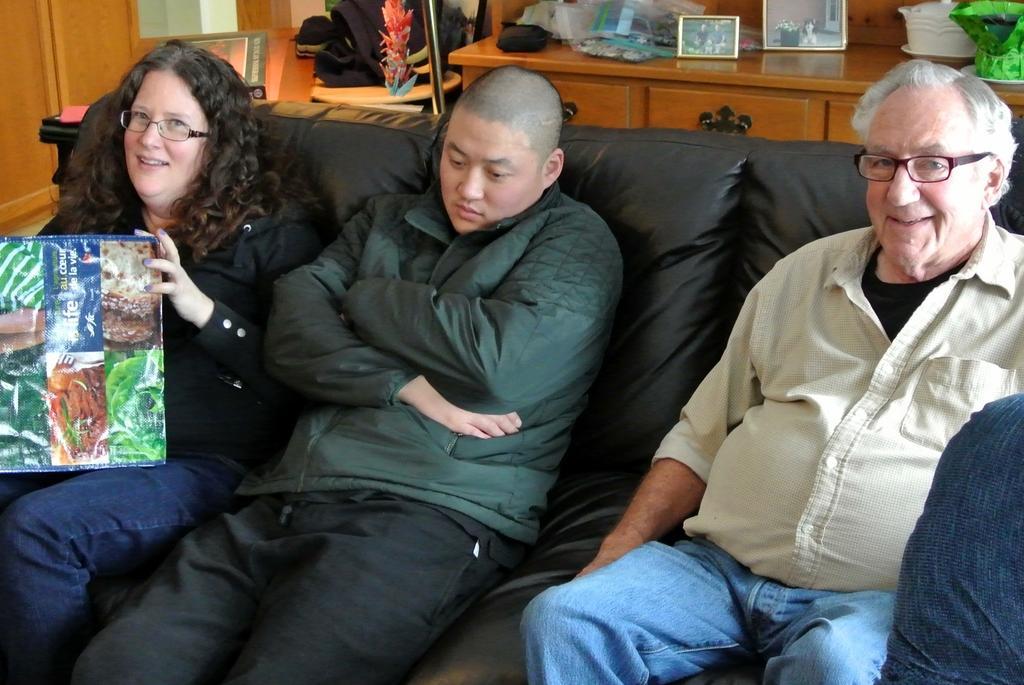How would you summarize this image in a sentence or two? In the image there are two men and a woman sitting on black sofa and behind them there is wooden table with photographs in it, on the left side there is a cupboard. 